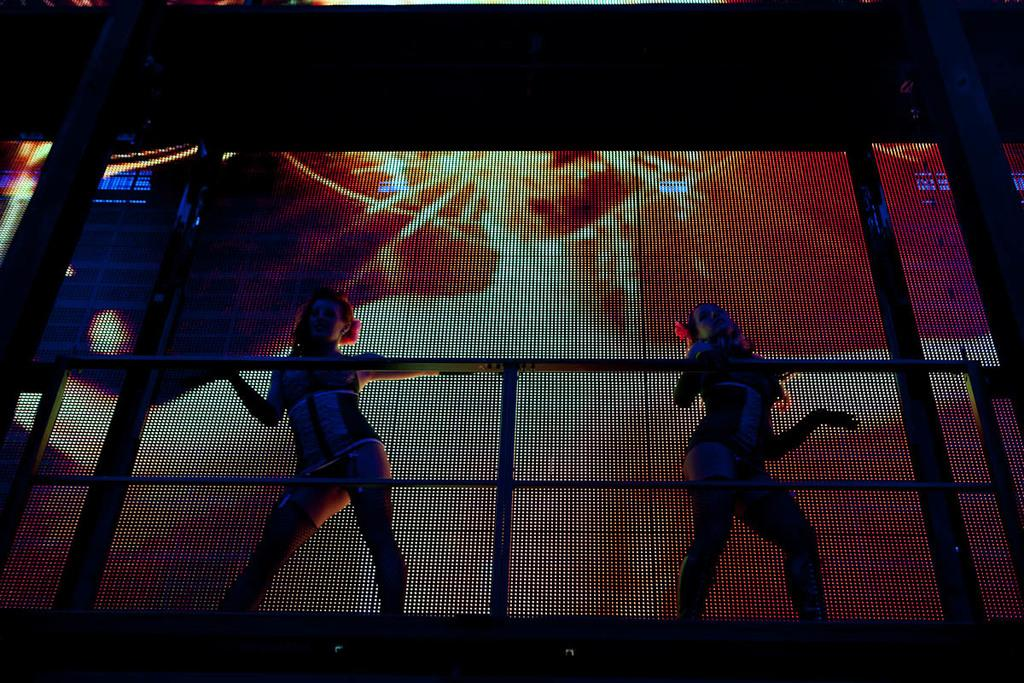What are the people in the image doing? The people in the image are performing dance. What can be seen near the people in the image? There are railings in the image. What is visible in the background of the image? In the background, there are screens with some effects. What type of comb is being used by the dancers in the image? There is no comb visible in the image, as the people are performing dance and not grooming their hair. 